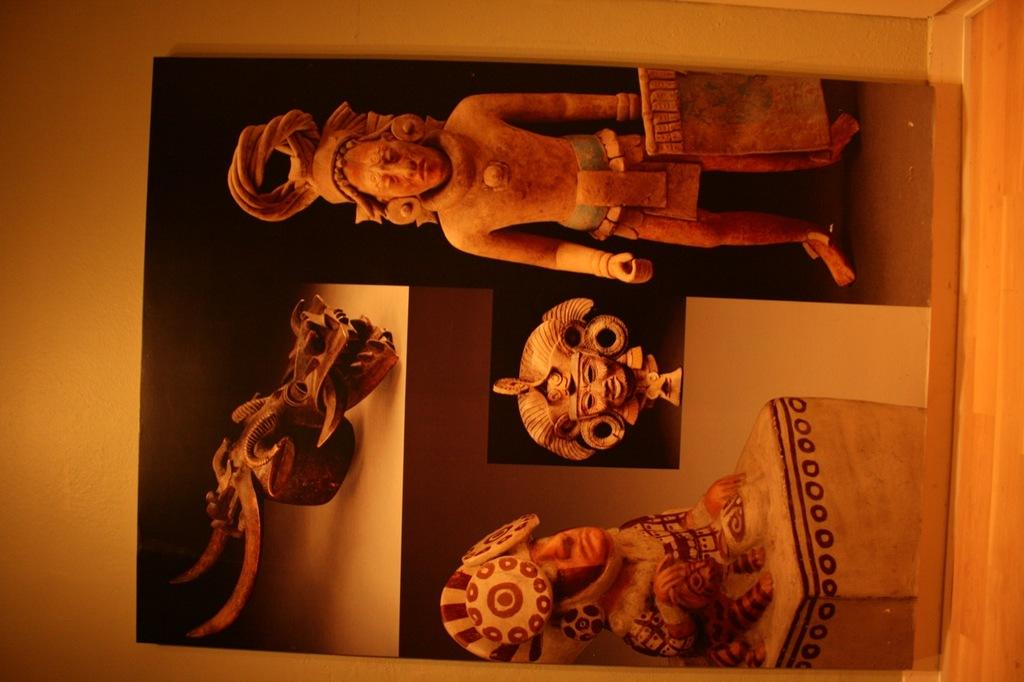What type of art pieces can be seen in the image? There are hand-carved statues and sculptures in the image. How are the statues and sculptures arranged in the image? The statues and sculptures are present in a rack. What type of butter is being used to create the sculptures in the image? There is no butter present in the image; the sculptures are made of a different material. 